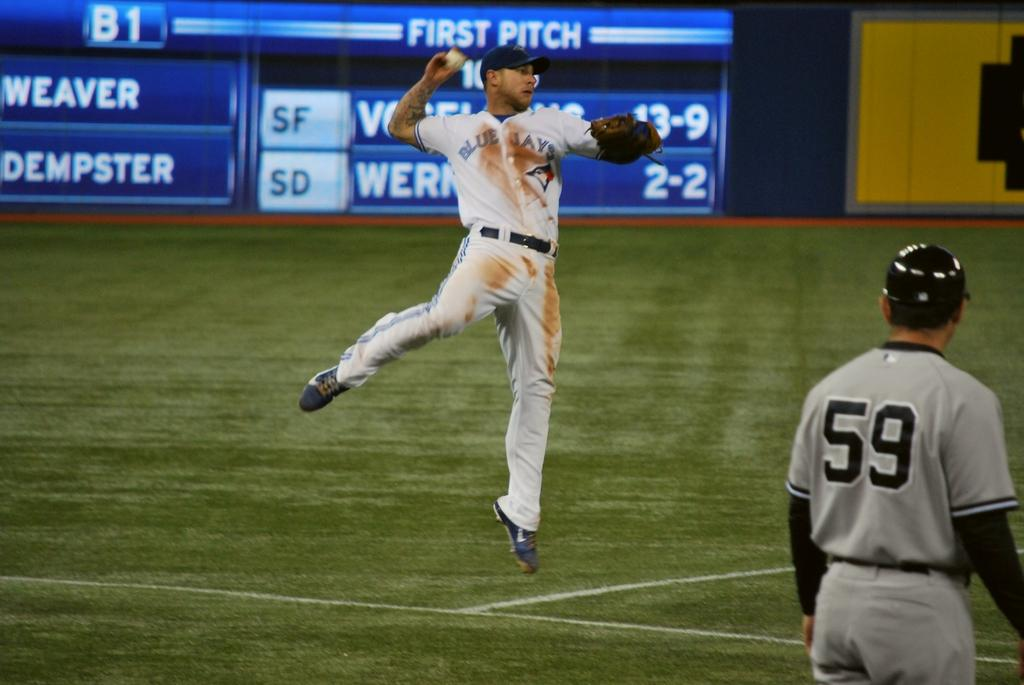<image>
Create a compact narrative representing the image presented. A baseball player in a dirty uniform with aonther having the number 59 on his back. 